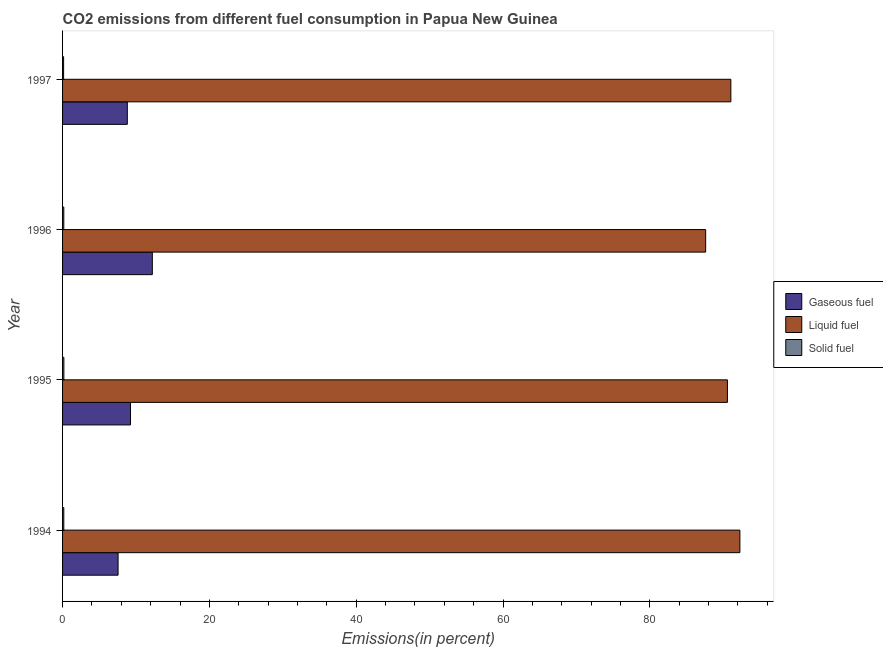How many different coloured bars are there?
Give a very brief answer. 3. Are the number of bars on each tick of the Y-axis equal?
Ensure brevity in your answer.  Yes. What is the label of the 2nd group of bars from the top?
Your response must be concise. 1996. In how many cases, is the number of bars for a given year not equal to the number of legend labels?
Provide a short and direct response. 0. What is the percentage of liquid fuel emission in 1996?
Ensure brevity in your answer.  87.6. Across all years, what is the maximum percentage of solid fuel emission?
Offer a terse response. 0.18. Across all years, what is the minimum percentage of gaseous fuel emission?
Your answer should be very brief. 7.56. In which year was the percentage of liquid fuel emission maximum?
Offer a terse response. 1994. What is the total percentage of liquid fuel emission in the graph?
Keep it short and to the point. 361.48. What is the difference between the percentage of liquid fuel emission in 1994 and that in 1996?
Ensure brevity in your answer.  4.66. What is the difference between the percentage of liquid fuel emission in 1997 and the percentage of solid fuel emission in 1995?
Give a very brief answer. 90.86. What is the average percentage of solid fuel emission per year?
Keep it short and to the point. 0.16. In the year 1994, what is the difference between the percentage of solid fuel emission and percentage of gaseous fuel emission?
Make the answer very short. -7.39. What is the ratio of the percentage of liquid fuel emission in 1994 to that in 1995?
Your answer should be compact. 1.02. Is the percentage of solid fuel emission in 1994 less than that in 1995?
Make the answer very short. Yes. Is the difference between the percentage of solid fuel emission in 1994 and 1996 greater than the difference between the percentage of gaseous fuel emission in 1994 and 1996?
Offer a terse response. Yes. What is the difference between the highest and the second highest percentage of solid fuel emission?
Make the answer very short. 0.01. Is the sum of the percentage of solid fuel emission in 1996 and 1997 greater than the maximum percentage of gaseous fuel emission across all years?
Ensure brevity in your answer.  No. What does the 3rd bar from the top in 1994 represents?
Make the answer very short. Gaseous fuel. What does the 3rd bar from the bottom in 1997 represents?
Offer a very short reply. Solid fuel. Are all the bars in the graph horizontal?
Give a very brief answer. Yes. How many years are there in the graph?
Make the answer very short. 4. Does the graph contain grids?
Provide a succinct answer. No. How many legend labels are there?
Offer a very short reply. 3. How are the legend labels stacked?
Keep it short and to the point. Vertical. What is the title of the graph?
Provide a short and direct response. CO2 emissions from different fuel consumption in Papua New Guinea. Does "Labor Market" appear as one of the legend labels in the graph?
Your response must be concise. No. What is the label or title of the X-axis?
Provide a short and direct response. Emissions(in percent). What is the label or title of the Y-axis?
Provide a short and direct response. Year. What is the Emissions(in percent) in Gaseous fuel in 1994?
Keep it short and to the point. 7.56. What is the Emissions(in percent) in Liquid fuel in 1994?
Give a very brief answer. 92.27. What is the Emissions(in percent) in Solid fuel in 1994?
Make the answer very short. 0.17. What is the Emissions(in percent) of Gaseous fuel in 1995?
Keep it short and to the point. 9.25. What is the Emissions(in percent) in Liquid fuel in 1995?
Offer a very short reply. 90.57. What is the Emissions(in percent) of Solid fuel in 1995?
Ensure brevity in your answer.  0.18. What is the Emissions(in percent) of Gaseous fuel in 1996?
Provide a succinct answer. 12.23. What is the Emissions(in percent) of Liquid fuel in 1996?
Give a very brief answer. 87.6. What is the Emissions(in percent) in Solid fuel in 1996?
Provide a succinct answer. 0.17. What is the Emissions(in percent) of Gaseous fuel in 1997?
Offer a very short reply. 8.82. What is the Emissions(in percent) of Liquid fuel in 1997?
Your response must be concise. 91.04. What is the Emissions(in percent) in Solid fuel in 1997?
Your answer should be very brief. 0.14. Across all years, what is the maximum Emissions(in percent) in Gaseous fuel?
Your response must be concise. 12.23. Across all years, what is the maximum Emissions(in percent) of Liquid fuel?
Offer a very short reply. 92.27. Across all years, what is the maximum Emissions(in percent) in Solid fuel?
Your answer should be very brief. 0.18. Across all years, what is the minimum Emissions(in percent) of Gaseous fuel?
Provide a short and direct response. 7.56. Across all years, what is the minimum Emissions(in percent) in Liquid fuel?
Offer a very short reply. 87.6. Across all years, what is the minimum Emissions(in percent) of Solid fuel?
Offer a very short reply. 0.14. What is the total Emissions(in percent) in Gaseous fuel in the graph?
Offer a terse response. 37.86. What is the total Emissions(in percent) in Liquid fuel in the graph?
Keep it short and to the point. 361.48. What is the total Emissions(in percent) of Solid fuel in the graph?
Your answer should be compact. 0.66. What is the difference between the Emissions(in percent) in Gaseous fuel in 1994 and that in 1995?
Provide a succinct answer. -1.69. What is the difference between the Emissions(in percent) in Liquid fuel in 1994 and that in 1995?
Give a very brief answer. 1.7. What is the difference between the Emissions(in percent) in Solid fuel in 1994 and that in 1995?
Ensure brevity in your answer.  -0.01. What is the difference between the Emissions(in percent) of Gaseous fuel in 1994 and that in 1996?
Offer a terse response. -4.66. What is the difference between the Emissions(in percent) in Liquid fuel in 1994 and that in 1996?
Give a very brief answer. 4.66. What is the difference between the Emissions(in percent) of Solid fuel in 1994 and that in 1996?
Keep it short and to the point. 0. What is the difference between the Emissions(in percent) in Gaseous fuel in 1994 and that in 1997?
Provide a succinct answer. -1.26. What is the difference between the Emissions(in percent) in Liquid fuel in 1994 and that in 1997?
Offer a terse response. 1.23. What is the difference between the Emissions(in percent) in Solid fuel in 1994 and that in 1997?
Provide a short and direct response. 0.03. What is the difference between the Emissions(in percent) of Gaseous fuel in 1995 and that in 1996?
Offer a terse response. -2.98. What is the difference between the Emissions(in percent) in Liquid fuel in 1995 and that in 1996?
Your answer should be compact. 2.96. What is the difference between the Emissions(in percent) in Solid fuel in 1995 and that in 1996?
Ensure brevity in your answer.  0.01. What is the difference between the Emissions(in percent) in Gaseous fuel in 1995 and that in 1997?
Make the answer very short. 0.43. What is the difference between the Emissions(in percent) in Liquid fuel in 1995 and that in 1997?
Offer a very short reply. -0.47. What is the difference between the Emissions(in percent) in Solid fuel in 1995 and that in 1997?
Ensure brevity in your answer.  0.04. What is the difference between the Emissions(in percent) in Gaseous fuel in 1996 and that in 1997?
Ensure brevity in your answer.  3.41. What is the difference between the Emissions(in percent) of Liquid fuel in 1996 and that in 1997?
Offer a very short reply. -3.43. What is the difference between the Emissions(in percent) in Solid fuel in 1996 and that in 1997?
Your answer should be compact. 0.03. What is the difference between the Emissions(in percent) of Gaseous fuel in 1994 and the Emissions(in percent) of Liquid fuel in 1995?
Provide a succinct answer. -83.01. What is the difference between the Emissions(in percent) in Gaseous fuel in 1994 and the Emissions(in percent) in Solid fuel in 1995?
Your response must be concise. 7.39. What is the difference between the Emissions(in percent) of Liquid fuel in 1994 and the Emissions(in percent) of Solid fuel in 1995?
Make the answer very short. 92.09. What is the difference between the Emissions(in percent) in Gaseous fuel in 1994 and the Emissions(in percent) in Liquid fuel in 1996?
Keep it short and to the point. -80.04. What is the difference between the Emissions(in percent) in Gaseous fuel in 1994 and the Emissions(in percent) in Solid fuel in 1996?
Make the answer very short. 7.4. What is the difference between the Emissions(in percent) of Liquid fuel in 1994 and the Emissions(in percent) of Solid fuel in 1996?
Your response must be concise. 92.1. What is the difference between the Emissions(in percent) of Gaseous fuel in 1994 and the Emissions(in percent) of Liquid fuel in 1997?
Offer a very short reply. -83.48. What is the difference between the Emissions(in percent) in Gaseous fuel in 1994 and the Emissions(in percent) in Solid fuel in 1997?
Provide a succinct answer. 7.42. What is the difference between the Emissions(in percent) in Liquid fuel in 1994 and the Emissions(in percent) in Solid fuel in 1997?
Provide a succinct answer. 92.13. What is the difference between the Emissions(in percent) of Gaseous fuel in 1995 and the Emissions(in percent) of Liquid fuel in 1996?
Your answer should be very brief. -78.35. What is the difference between the Emissions(in percent) in Gaseous fuel in 1995 and the Emissions(in percent) in Solid fuel in 1996?
Your answer should be very brief. 9.09. What is the difference between the Emissions(in percent) in Liquid fuel in 1995 and the Emissions(in percent) in Solid fuel in 1996?
Give a very brief answer. 90.4. What is the difference between the Emissions(in percent) of Gaseous fuel in 1995 and the Emissions(in percent) of Liquid fuel in 1997?
Offer a very short reply. -81.79. What is the difference between the Emissions(in percent) of Gaseous fuel in 1995 and the Emissions(in percent) of Solid fuel in 1997?
Your answer should be compact. 9.11. What is the difference between the Emissions(in percent) in Liquid fuel in 1995 and the Emissions(in percent) in Solid fuel in 1997?
Provide a succinct answer. 90.43. What is the difference between the Emissions(in percent) of Gaseous fuel in 1996 and the Emissions(in percent) of Liquid fuel in 1997?
Provide a succinct answer. -78.81. What is the difference between the Emissions(in percent) in Gaseous fuel in 1996 and the Emissions(in percent) in Solid fuel in 1997?
Keep it short and to the point. 12.09. What is the difference between the Emissions(in percent) in Liquid fuel in 1996 and the Emissions(in percent) in Solid fuel in 1997?
Provide a succinct answer. 87.46. What is the average Emissions(in percent) in Gaseous fuel per year?
Your answer should be compact. 9.47. What is the average Emissions(in percent) in Liquid fuel per year?
Give a very brief answer. 90.37. What is the average Emissions(in percent) of Solid fuel per year?
Provide a succinct answer. 0.16. In the year 1994, what is the difference between the Emissions(in percent) in Gaseous fuel and Emissions(in percent) in Liquid fuel?
Offer a very short reply. -84.71. In the year 1994, what is the difference between the Emissions(in percent) in Gaseous fuel and Emissions(in percent) in Solid fuel?
Provide a short and direct response. 7.39. In the year 1994, what is the difference between the Emissions(in percent) in Liquid fuel and Emissions(in percent) in Solid fuel?
Provide a succinct answer. 92.1. In the year 1995, what is the difference between the Emissions(in percent) of Gaseous fuel and Emissions(in percent) of Liquid fuel?
Give a very brief answer. -81.32. In the year 1995, what is the difference between the Emissions(in percent) of Gaseous fuel and Emissions(in percent) of Solid fuel?
Offer a terse response. 9.07. In the year 1995, what is the difference between the Emissions(in percent) of Liquid fuel and Emissions(in percent) of Solid fuel?
Keep it short and to the point. 90.39. In the year 1996, what is the difference between the Emissions(in percent) in Gaseous fuel and Emissions(in percent) in Liquid fuel?
Your response must be concise. -75.38. In the year 1996, what is the difference between the Emissions(in percent) in Gaseous fuel and Emissions(in percent) in Solid fuel?
Offer a terse response. 12.06. In the year 1996, what is the difference between the Emissions(in percent) in Liquid fuel and Emissions(in percent) in Solid fuel?
Keep it short and to the point. 87.44. In the year 1997, what is the difference between the Emissions(in percent) in Gaseous fuel and Emissions(in percent) in Liquid fuel?
Provide a short and direct response. -82.22. In the year 1997, what is the difference between the Emissions(in percent) of Gaseous fuel and Emissions(in percent) of Solid fuel?
Your response must be concise. 8.68. In the year 1997, what is the difference between the Emissions(in percent) in Liquid fuel and Emissions(in percent) in Solid fuel?
Your response must be concise. 90.9. What is the ratio of the Emissions(in percent) of Gaseous fuel in 1994 to that in 1995?
Provide a succinct answer. 0.82. What is the ratio of the Emissions(in percent) of Liquid fuel in 1994 to that in 1995?
Your response must be concise. 1.02. What is the ratio of the Emissions(in percent) in Solid fuel in 1994 to that in 1995?
Ensure brevity in your answer.  0.94. What is the ratio of the Emissions(in percent) of Gaseous fuel in 1994 to that in 1996?
Your response must be concise. 0.62. What is the ratio of the Emissions(in percent) of Liquid fuel in 1994 to that in 1996?
Your response must be concise. 1.05. What is the ratio of the Emissions(in percent) of Gaseous fuel in 1994 to that in 1997?
Keep it short and to the point. 0.86. What is the ratio of the Emissions(in percent) in Liquid fuel in 1994 to that in 1997?
Give a very brief answer. 1.01. What is the ratio of the Emissions(in percent) in Solid fuel in 1994 to that in 1997?
Ensure brevity in your answer.  1.18. What is the ratio of the Emissions(in percent) of Gaseous fuel in 1995 to that in 1996?
Give a very brief answer. 0.76. What is the ratio of the Emissions(in percent) in Liquid fuel in 1995 to that in 1996?
Make the answer very short. 1.03. What is the ratio of the Emissions(in percent) in Solid fuel in 1995 to that in 1996?
Your answer should be very brief. 1.06. What is the ratio of the Emissions(in percent) of Gaseous fuel in 1995 to that in 1997?
Your response must be concise. 1.05. What is the ratio of the Emissions(in percent) in Liquid fuel in 1995 to that in 1997?
Keep it short and to the point. 0.99. What is the ratio of the Emissions(in percent) of Solid fuel in 1995 to that in 1997?
Keep it short and to the point. 1.25. What is the ratio of the Emissions(in percent) of Gaseous fuel in 1996 to that in 1997?
Your answer should be compact. 1.39. What is the ratio of the Emissions(in percent) of Liquid fuel in 1996 to that in 1997?
Ensure brevity in your answer.  0.96. What is the ratio of the Emissions(in percent) of Solid fuel in 1996 to that in 1997?
Give a very brief answer. 1.18. What is the difference between the highest and the second highest Emissions(in percent) of Gaseous fuel?
Keep it short and to the point. 2.98. What is the difference between the highest and the second highest Emissions(in percent) of Liquid fuel?
Offer a terse response. 1.23. What is the difference between the highest and the second highest Emissions(in percent) of Solid fuel?
Make the answer very short. 0.01. What is the difference between the highest and the lowest Emissions(in percent) in Gaseous fuel?
Provide a short and direct response. 4.66. What is the difference between the highest and the lowest Emissions(in percent) of Liquid fuel?
Your response must be concise. 4.66. What is the difference between the highest and the lowest Emissions(in percent) in Solid fuel?
Offer a terse response. 0.04. 